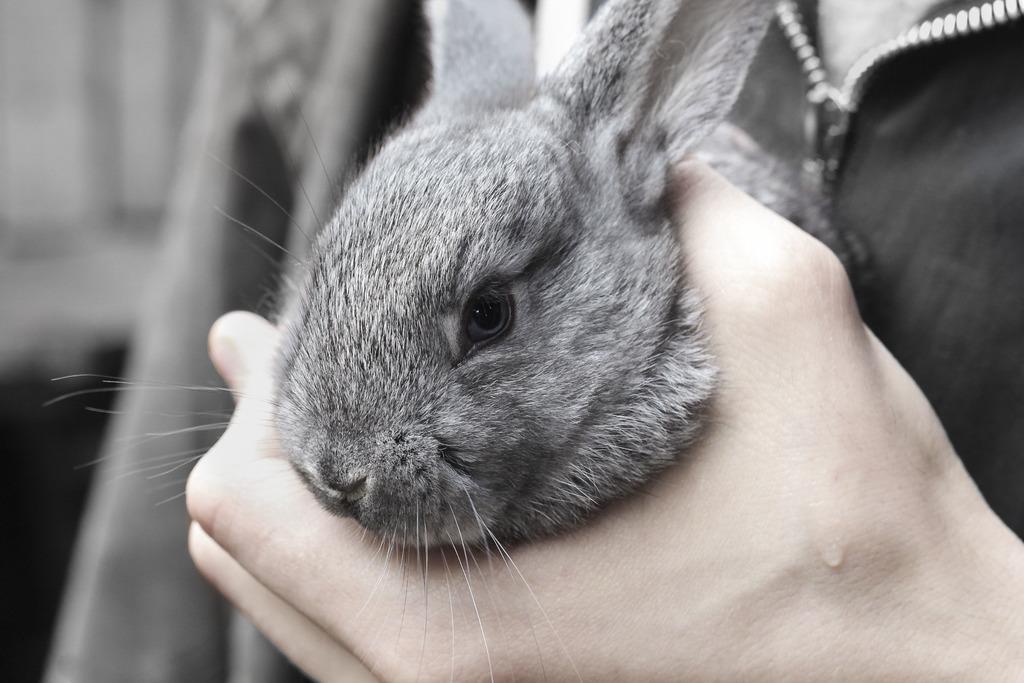In one or two sentences, can you explain what this image depicts? In this image I can see hand of a person in the front and I can see a rabbit in the hand. I can also see this image is little bit blurry in the background. 